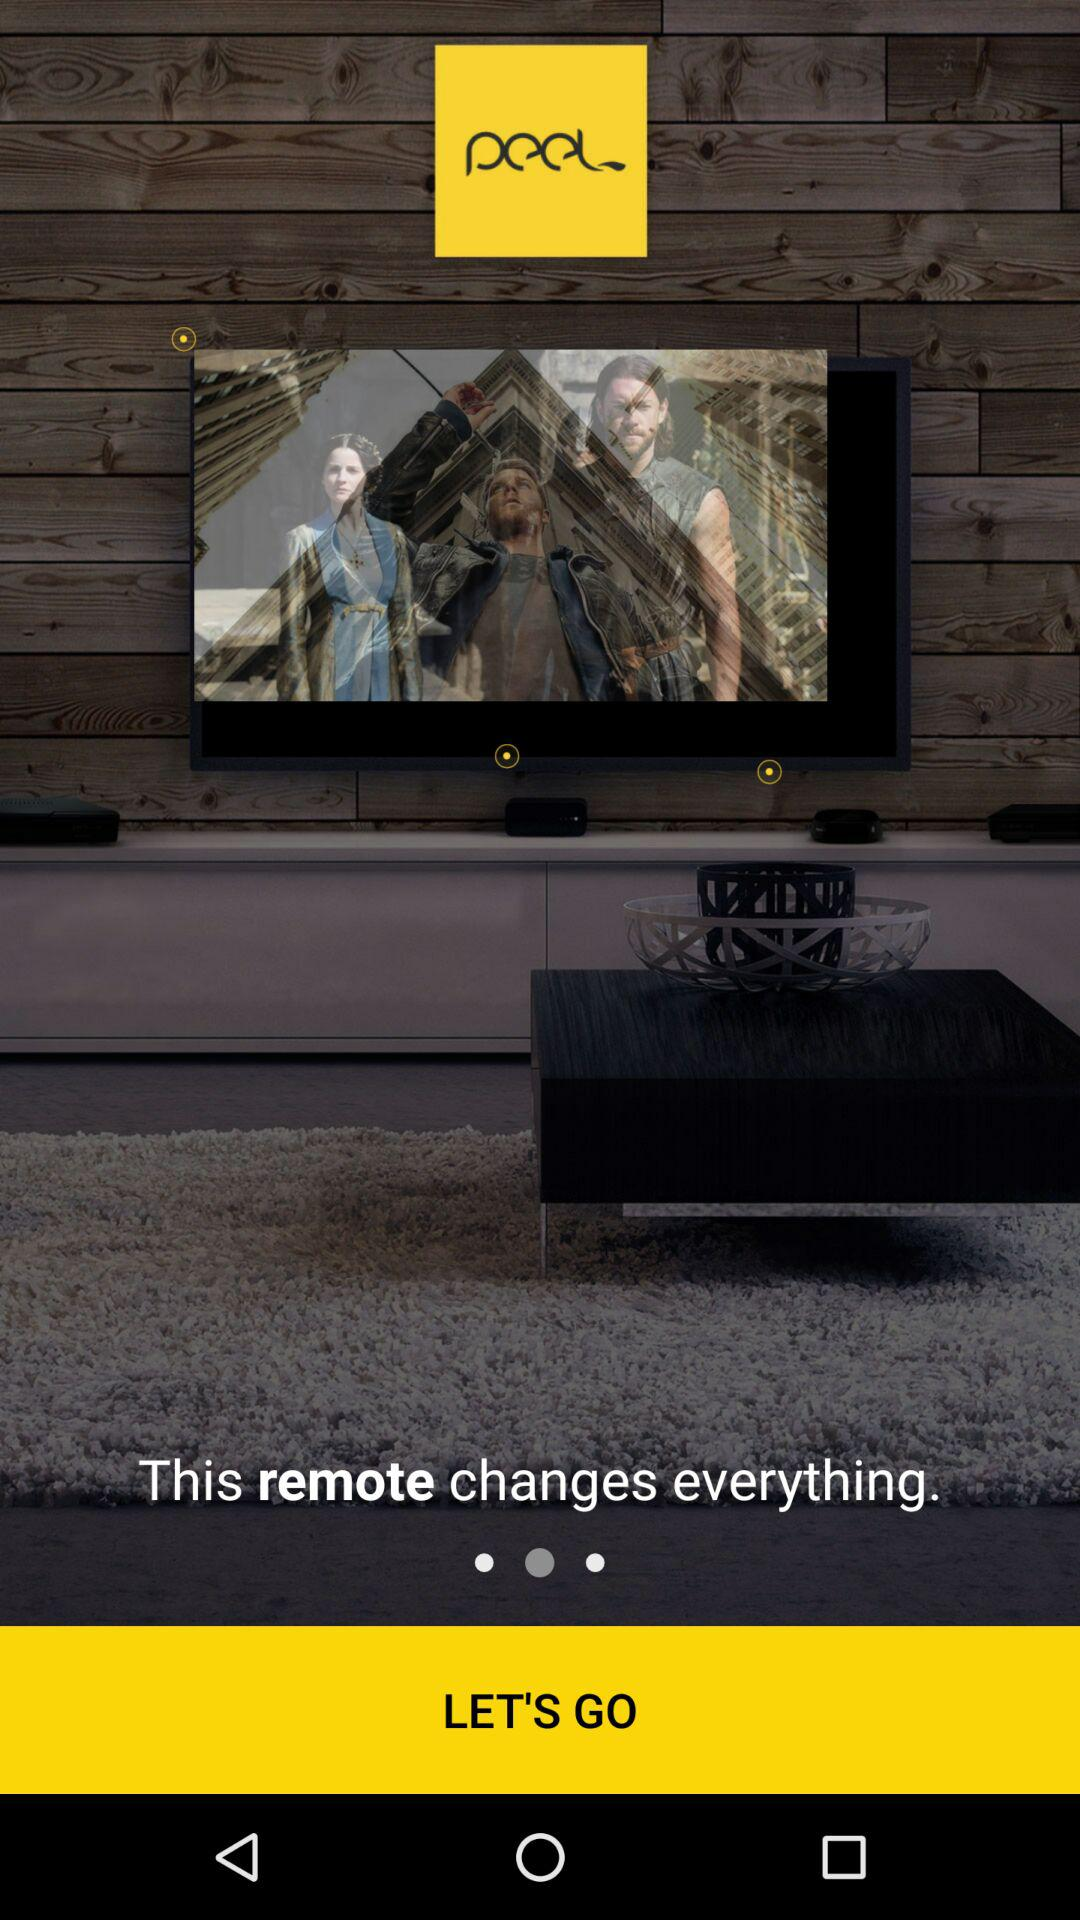How many pager indicators are there?
Answer the question using a single word or phrase. 1 